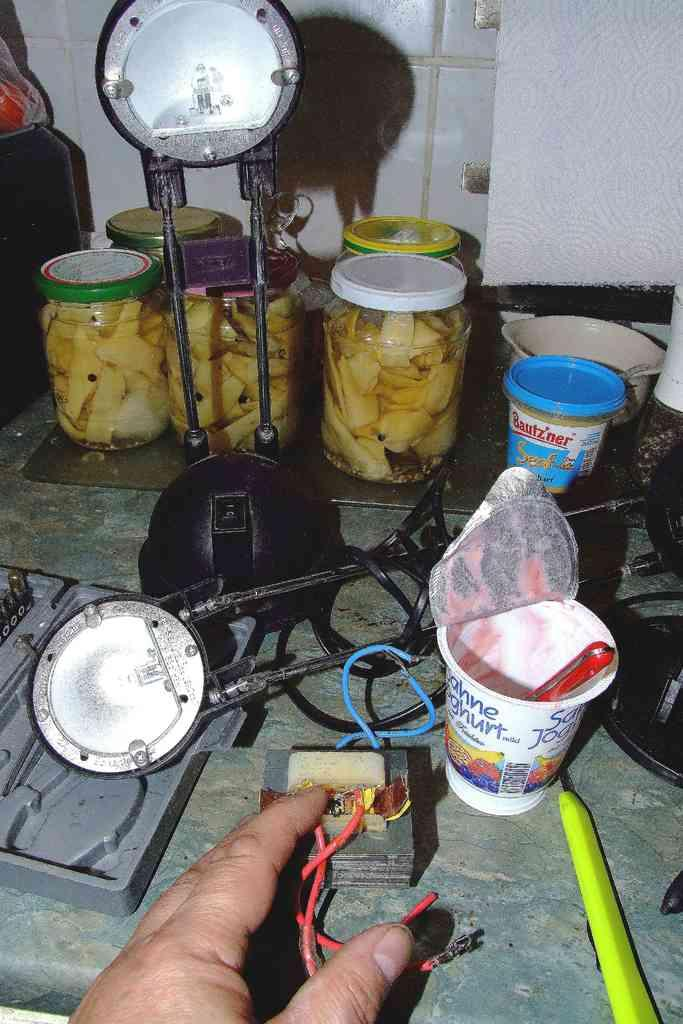What part of a person can be seen in the image? There is a hand of a person in the image. What is located on the floor in the image? There are objects placed on the floor in the image. How many ladybugs can be seen on the wall in the image? There is no wall or ladybugs present in the image. 